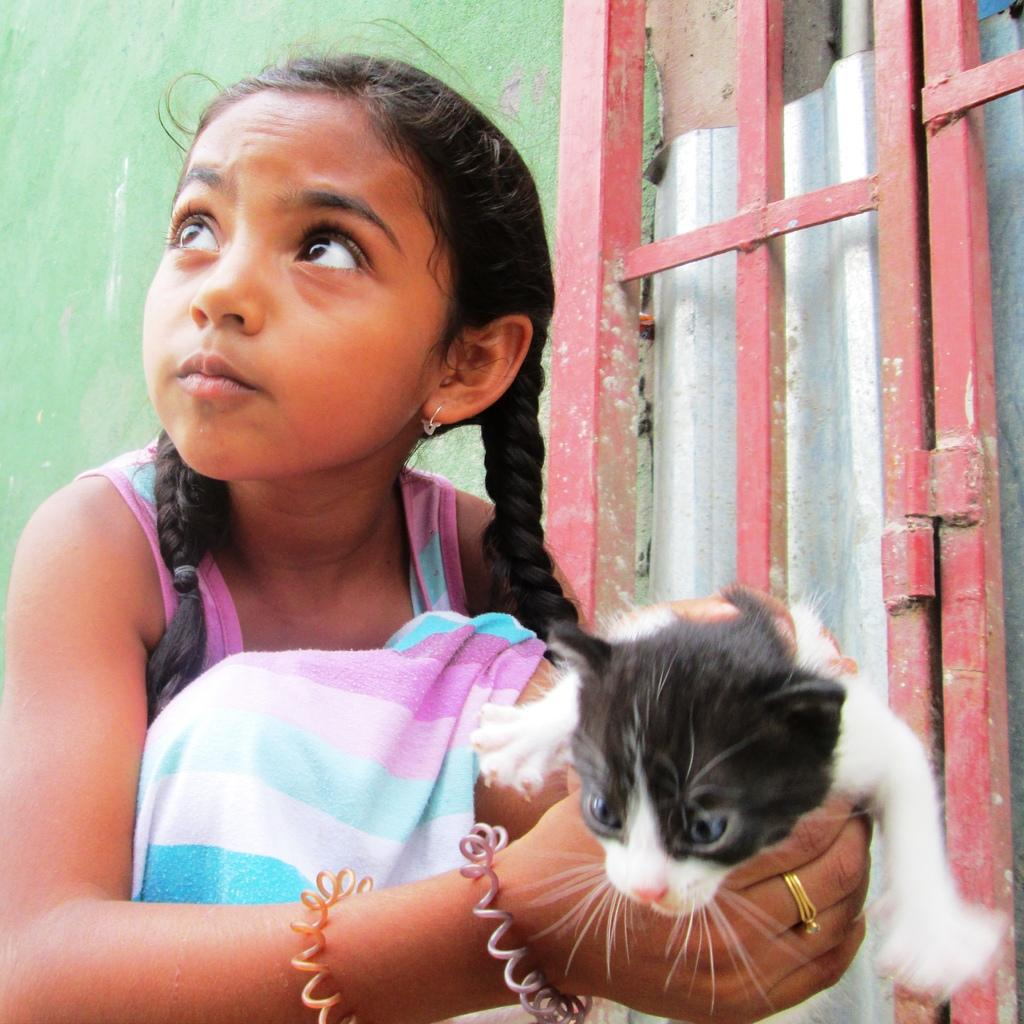Who is the main subject in the image? There is a girl in the image. What is the girl holding in the image? The girl is holding a cat. Can you describe the other girl in the image? There is another girl beside her, and she is wearing red color. What type of laborer is working in the background of the image? There is no laborer present in the image, as it primarily features the two girls and the cat. 